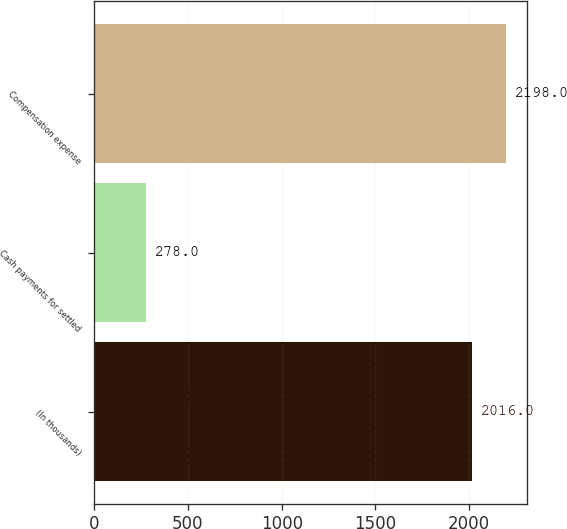Convert chart. <chart><loc_0><loc_0><loc_500><loc_500><bar_chart><fcel>(In thousands)<fcel>Cash payments for settled<fcel>Compensation expense<nl><fcel>2016<fcel>278<fcel>2198<nl></chart> 